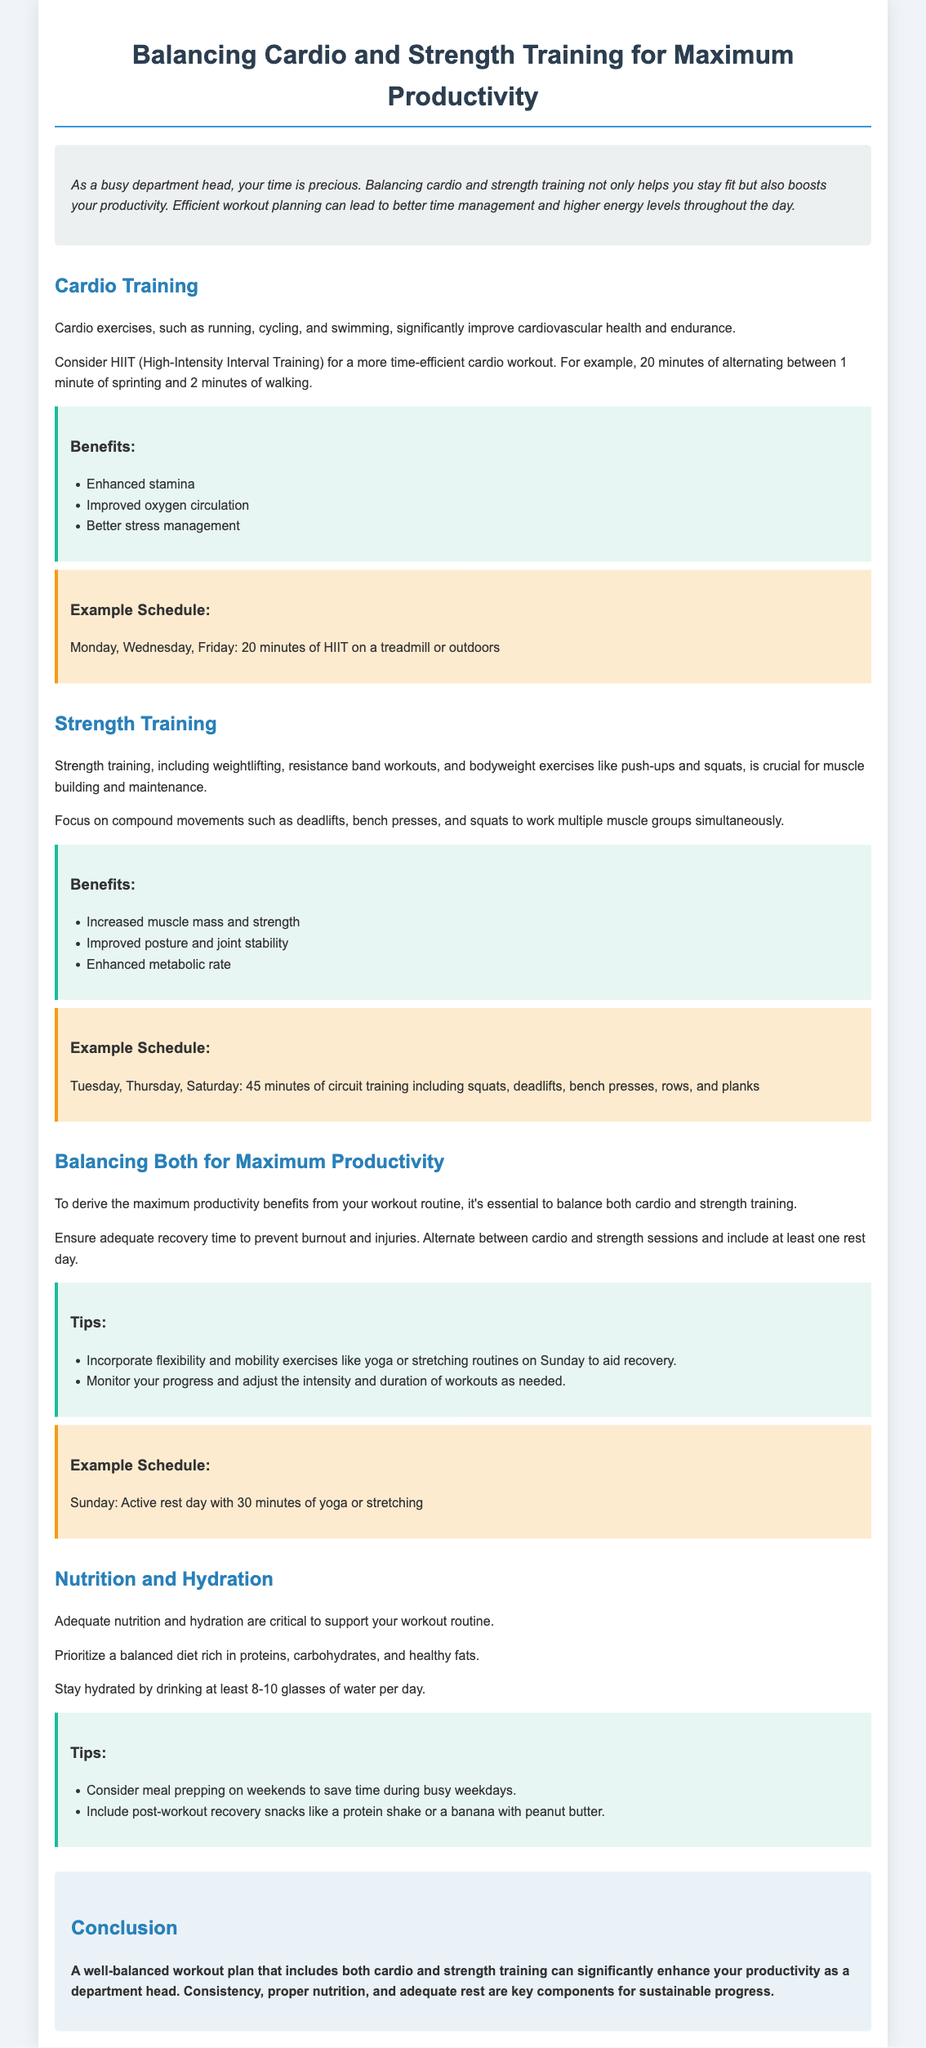What is the primary focus of the workout plan? The workout plan focuses on balancing cardio and strength training to enhance productivity.
Answer: Balancing cardio and strength training How many days a week is cardio recommended? The recommended cardio workout schedule includes three days a week: Monday, Wednesday, and Friday.
Answer: Three days What type of cardio exercise is mentioned for efficiency? High-Intensity Interval Training (HIIT) is suggested as a time-efficient cardio workout.
Answer: HIIT What is one of the benefits of strength training listed? Strength training benefits include increased muscle mass and strength.
Answer: Increased muscle mass and strength Which day is suggested for active rest? Sunday is recommended as an active rest day with yoga or stretching.
Answer: Sunday What should be prioritized in a balanced diet? A balanced diet should be rich in proteins, carbohydrates, and healthy fats.
Answer: Balanced diet rich in proteins, carbohydrates, and healthy fats How many glasses of water should be consumed daily? It is advised to drink at least 8-10 glasses of water per day.
Answer: 8-10 glasses What exercise types are encouraged for flexibility and mobility? Flexibility and mobility exercises like yoga or stretching are encouraged.
Answer: Yoga or stretching What is the purpose of meal prepping mentioned in the document? Meal prepping is suggested to save time during busy weekdays.
Answer: Save time during busy weekdays 